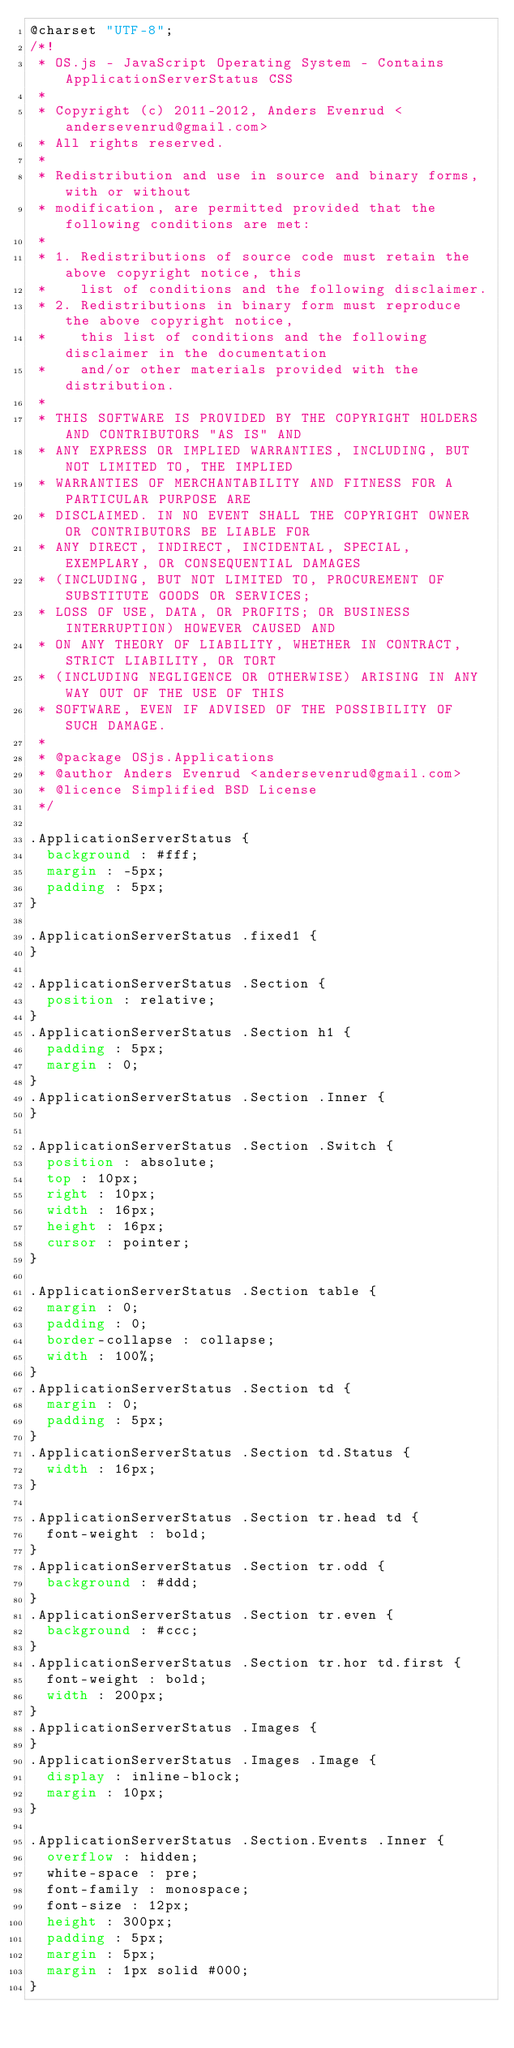Convert code to text. <code><loc_0><loc_0><loc_500><loc_500><_CSS_>@charset "UTF-8";
/*!
 * OS.js - JavaScript Operating System - Contains ApplicationServerStatus CSS
 *
 * Copyright (c) 2011-2012, Anders Evenrud <andersevenrud@gmail.com>
 * All rights reserved.
 * 
 * Redistribution and use in source and binary forms, with or without
 * modification, are permitted provided that the following conditions are met: 
 * 
 * 1. Redistributions of source code must retain the above copyright notice, this
 *    list of conditions and the following disclaimer. 
 * 2. Redistributions in binary form must reproduce the above copyright notice,
 *    this list of conditions and the following disclaimer in the documentation
 *    and/or other materials provided with the distribution. 
 * 
 * THIS SOFTWARE IS PROVIDED BY THE COPYRIGHT HOLDERS AND CONTRIBUTORS "AS IS" AND
 * ANY EXPRESS OR IMPLIED WARRANTIES, INCLUDING, BUT NOT LIMITED TO, THE IMPLIED
 * WARRANTIES OF MERCHANTABILITY AND FITNESS FOR A PARTICULAR PURPOSE ARE
 * DISCLAIMED. IN NO EVENT SHALL THE COPYRIGHT OWNER OR CONTRIBUTORS BE LIABLE FOR
 * ANY DIRECT, INDIRECT, INCIDENTAL, SPECIAL, EXEMPLARY, OR CONSEQUENTIAL DAMAGES
 * (INCLUDING, BUT NOT LIMITED TO, PROCUREMENT OF SUBSTITUTE GOODS OR SERVICES;
 * LOSS OF USE, DATA, OR PROFITS; OR BUSINESS INTERRUPTION) HOWEVER CAUSED AND
 * ON ANY THEORY OF LIABILITY, WHETHER IN CONTRACT, STRICT LIABILITY, OR TORT
 * (INCLUDING NEGLIGENCE OR OTHERWISE) ARISING IN ANY WAY OUT OF THE USE OF THIS
 * SOFTWARE, EVEN IF ADVISED OF THE POSSIBILITY OF SUCH DAMAGE.
 *
 * @package OSjs.Applications
 * @author Anders Evenrud <andersevenrud@gmail.com>
 * @licence Simplified BSD License
 */

.ApplicationServerStatus {
  background : #fff;
  margin : -5px;
  padding : 5px;
}

.ApplicationServerStatus .fixed1 {
}

.ApplicationServerStatus .Section {
  position : relative;
}
.ApplicationServerStatus .Section h1 {
  padding : 5px;
  margin : 0;
}
.ApplicationServerStatus .Section .Inner {
}

.ApplicationServerStatus .Section .Switch {
  position : absolute;
  top : 10px;
  right : 10px;
  width : 16px;
  height : 16px;
  cursor : pointer;
}

.ApplicationServerStatus .Section table {
  margin : 0;
  padding : 0;
  border-collapse : collapse;
  width : 100%;
}
.ApplicationServerStatus .Section td {
  margin : 0;
  padding : 5px;
}
.ApplicationServerStatus .Section td.Status {
  width : 16px;
}

.ApplicationServerStatus .Section tr.head td {
  font-weight : bold;
}
.ApplicationServerStatus .Section tr.odd {
  background : #ddd;
}
.ApplicationServerStatus .Section tr.even {
  background : #ccc;
}
.ApplicationServerStatus .Section tr.hor td.first {
  font-weight : bold;
  width : 200px;
}
.ApplicationServerStatus .Images {
}
.ApplicationServerStatus .Images .Image {
  display : inline-block;
  margin : 10px;
}

.ApplicationServerStatus .Section.Events .Inner {
  overflow : hidden;
  white-space : pre;
  font-family : monospace;
  font-size : 12px;
  height : 300px;
  padding : 5px;
  margin : 5px;
  margin : 1px solid #000;
}
</code> 